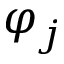<formula> <loc_0><loc_0><loc_500><loc_500>\varphi _ { j }</formula> 